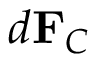Convert formula to latex. <formula><loc_0><loc_0><loc_500><loc_500>d F _ { C } \,</formula> 